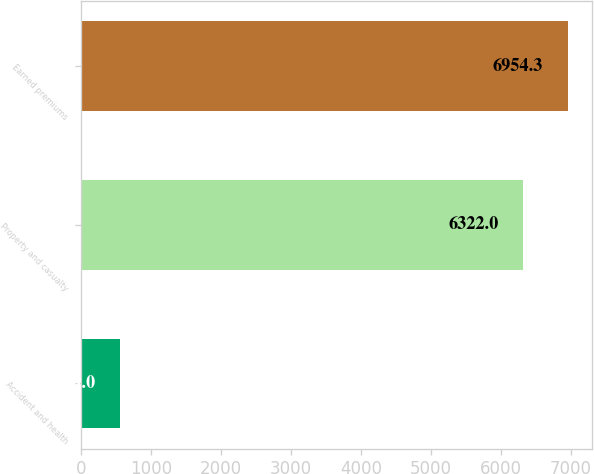Convert chart to OTSL. <chart><loc_0><loc_0><loc_500><loc_500><bar_chart><fcel>Accident and health<fcel>Property and casualty<fcel>Earned premiums<nl><fcel>559<fcel>6322<fcel>6954.3<nl></chart> 